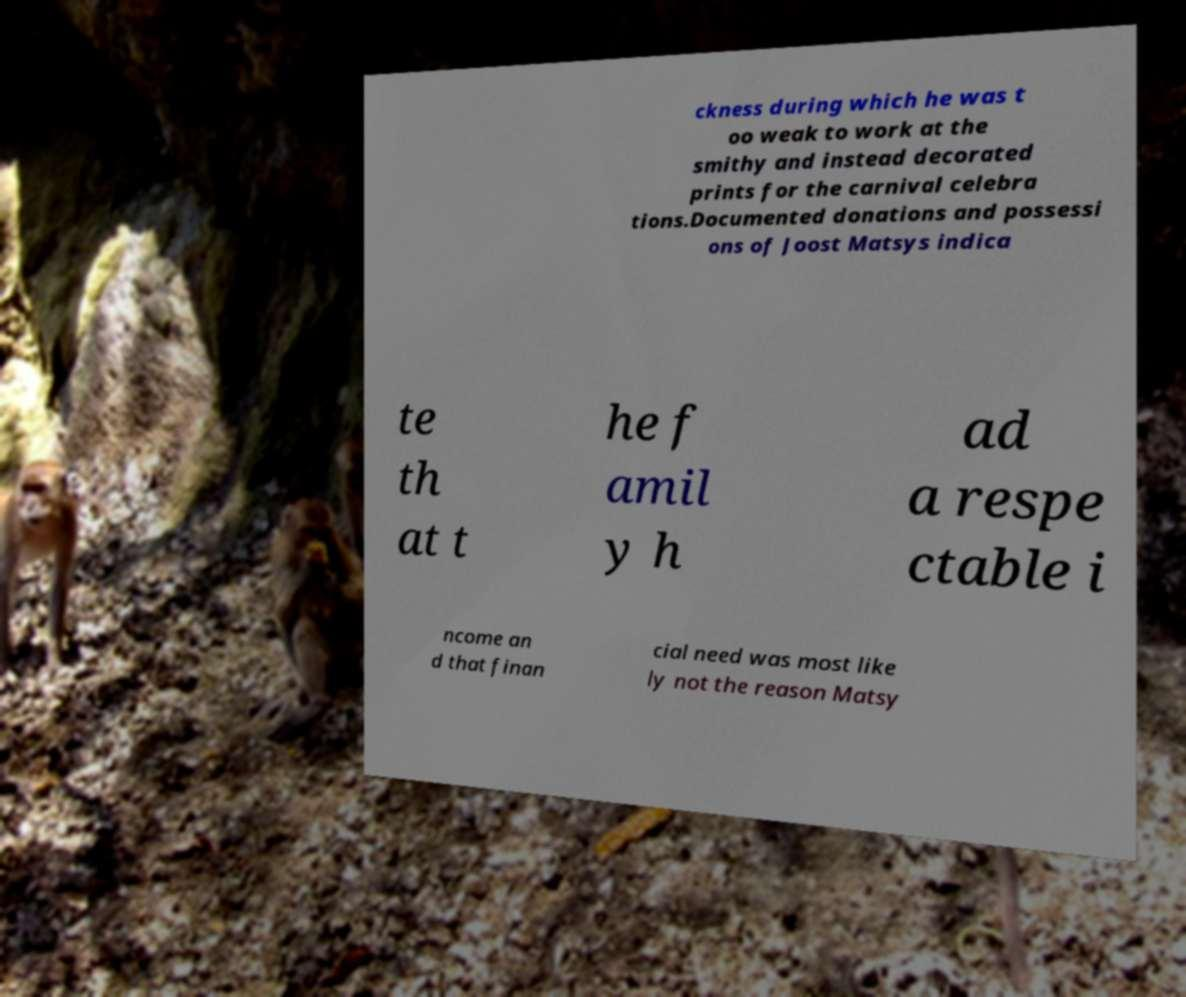For documentation purposes, I need the text within this image transcribed. Could you provide that? ckness during which he was t oo weak to work at the smithy and instead decorated prints for the carnival celebra tions.Documented donations and possessi ons of Joost Matsys indica te th at t he f amil y h ad a respe ctable i ncome an d that finan cial need was most like ly not the reason Matsy 